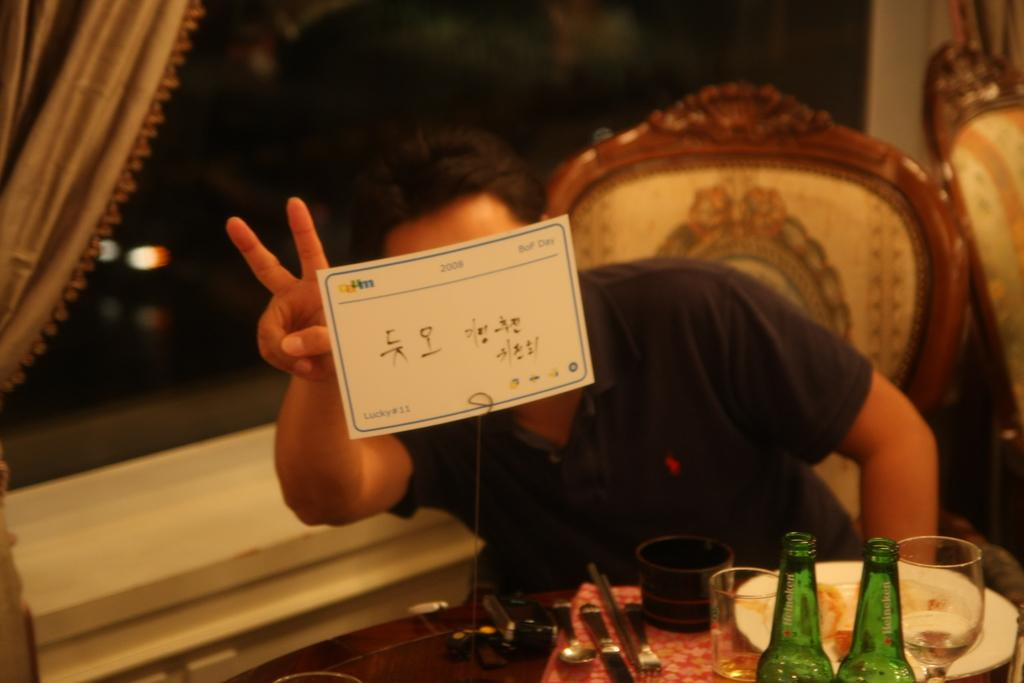What is the man in the image doing? The man is sitting on a chair in the image. Where is the man located in relation to the table? The man is in front of a table in the image. What can be seen on the table in the image? There are objects on the table in the image. What type of airplane is the man flying in the image? There is no airplane present in the image; the man is sitting on a chair in front of a table. What is the man's interest in the objects on the table? The facts provided do not give any information about the man's interest in the objects on the table. 